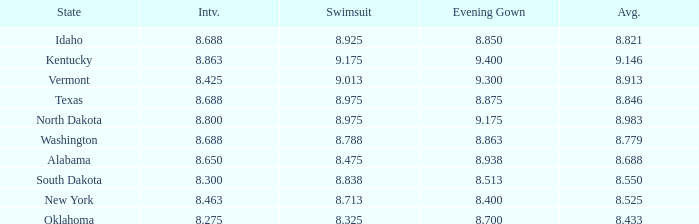What is the highest average of the contestant from Texas with an evening gown larger than 8.875? None. 